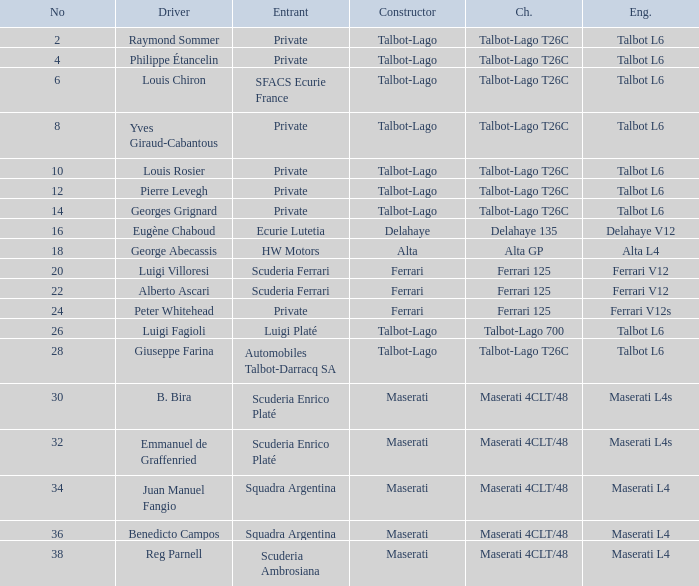Name the chassis for b. bira Maserati 4CLT/48. 